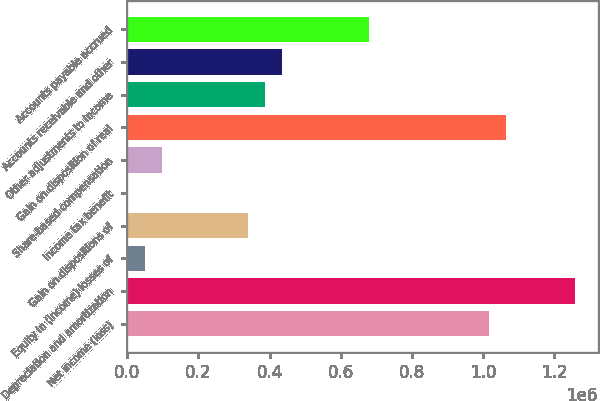Convert chart to OTSL. <chart><loc_0><loc_0><loc_500><loc_500><bar_chart><fcel>Net income (loss)<fcel>Depreciation and amortization<fcel>Equity in (income) losses of<fcel>Gain on dispositions of<fcel>Income tax benefit<fcel>Share-based compensation<fcel>Gain on disposition of real<fcel>Other adjustments to income<fcel>Accounts receivable and other<fcel>Accounts payable accrued<nl><fcel>1.01735e+06<fcel>1.25938e+06<fcel>49262.6<fcel>339690<fcel>858<fcel>97667.2<fcel>1.06576e+06<fcel>388095<fcel>436499<fcel>678522<nl></chart> 